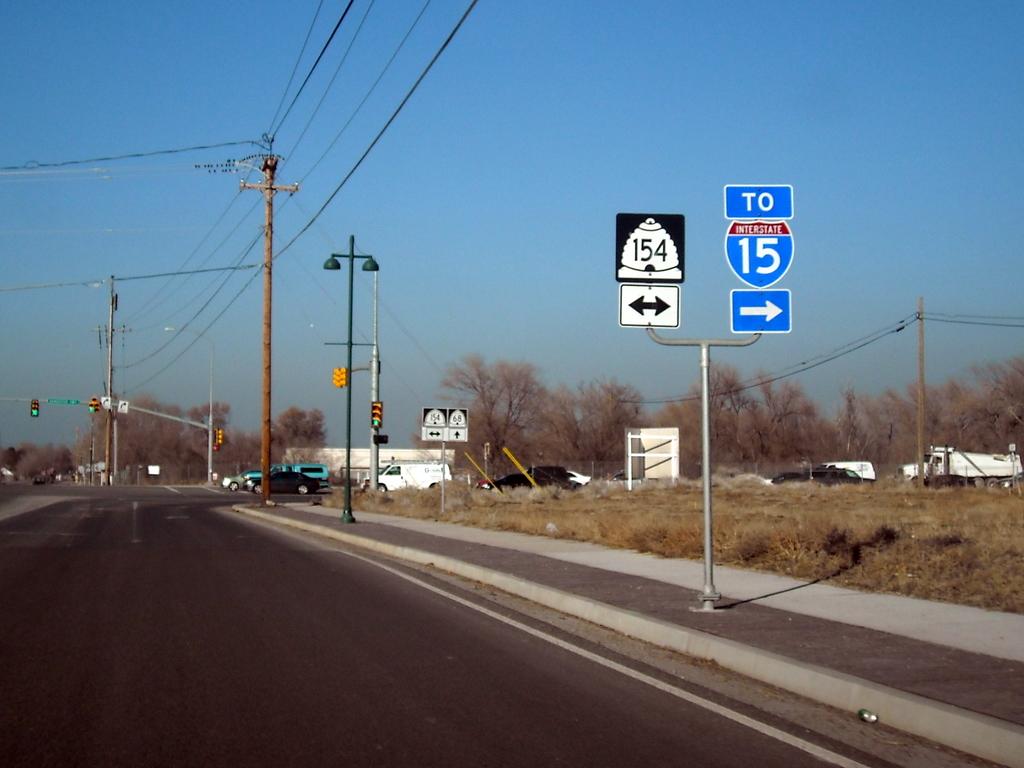Which way to highway 15?
Make the answer very short. Right. What number route is ahead?
Give a very brief answer. 154. 